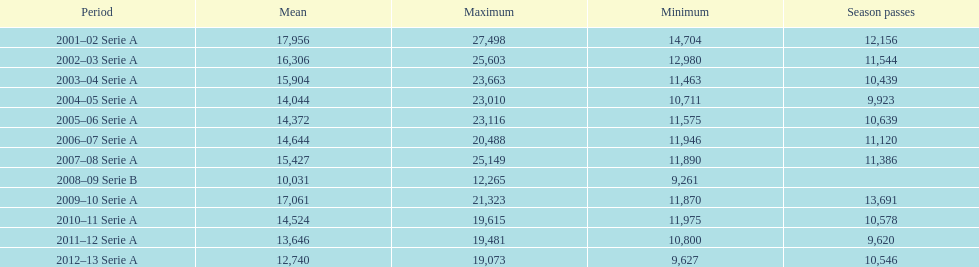What was the number of season tickets in 2007? 11,386. 